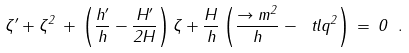<formula> <loc_0><loc_0><loc_500><loc_500>\label l { n u _ { e } q } \zeta ^ { \prime } + \zeta ^ { 2 } \, + \, \left ( \frac { h ^ { \prime } } { h } - \frac { H ^ { \prime } } { 2 H } \right ) \zeta + \frac { H } { h } \left ( \frac { \to m ^ { 2 } } { h } - \ t l q ^ { 2 } \right ) \, = \, 0 \ .</formula> 